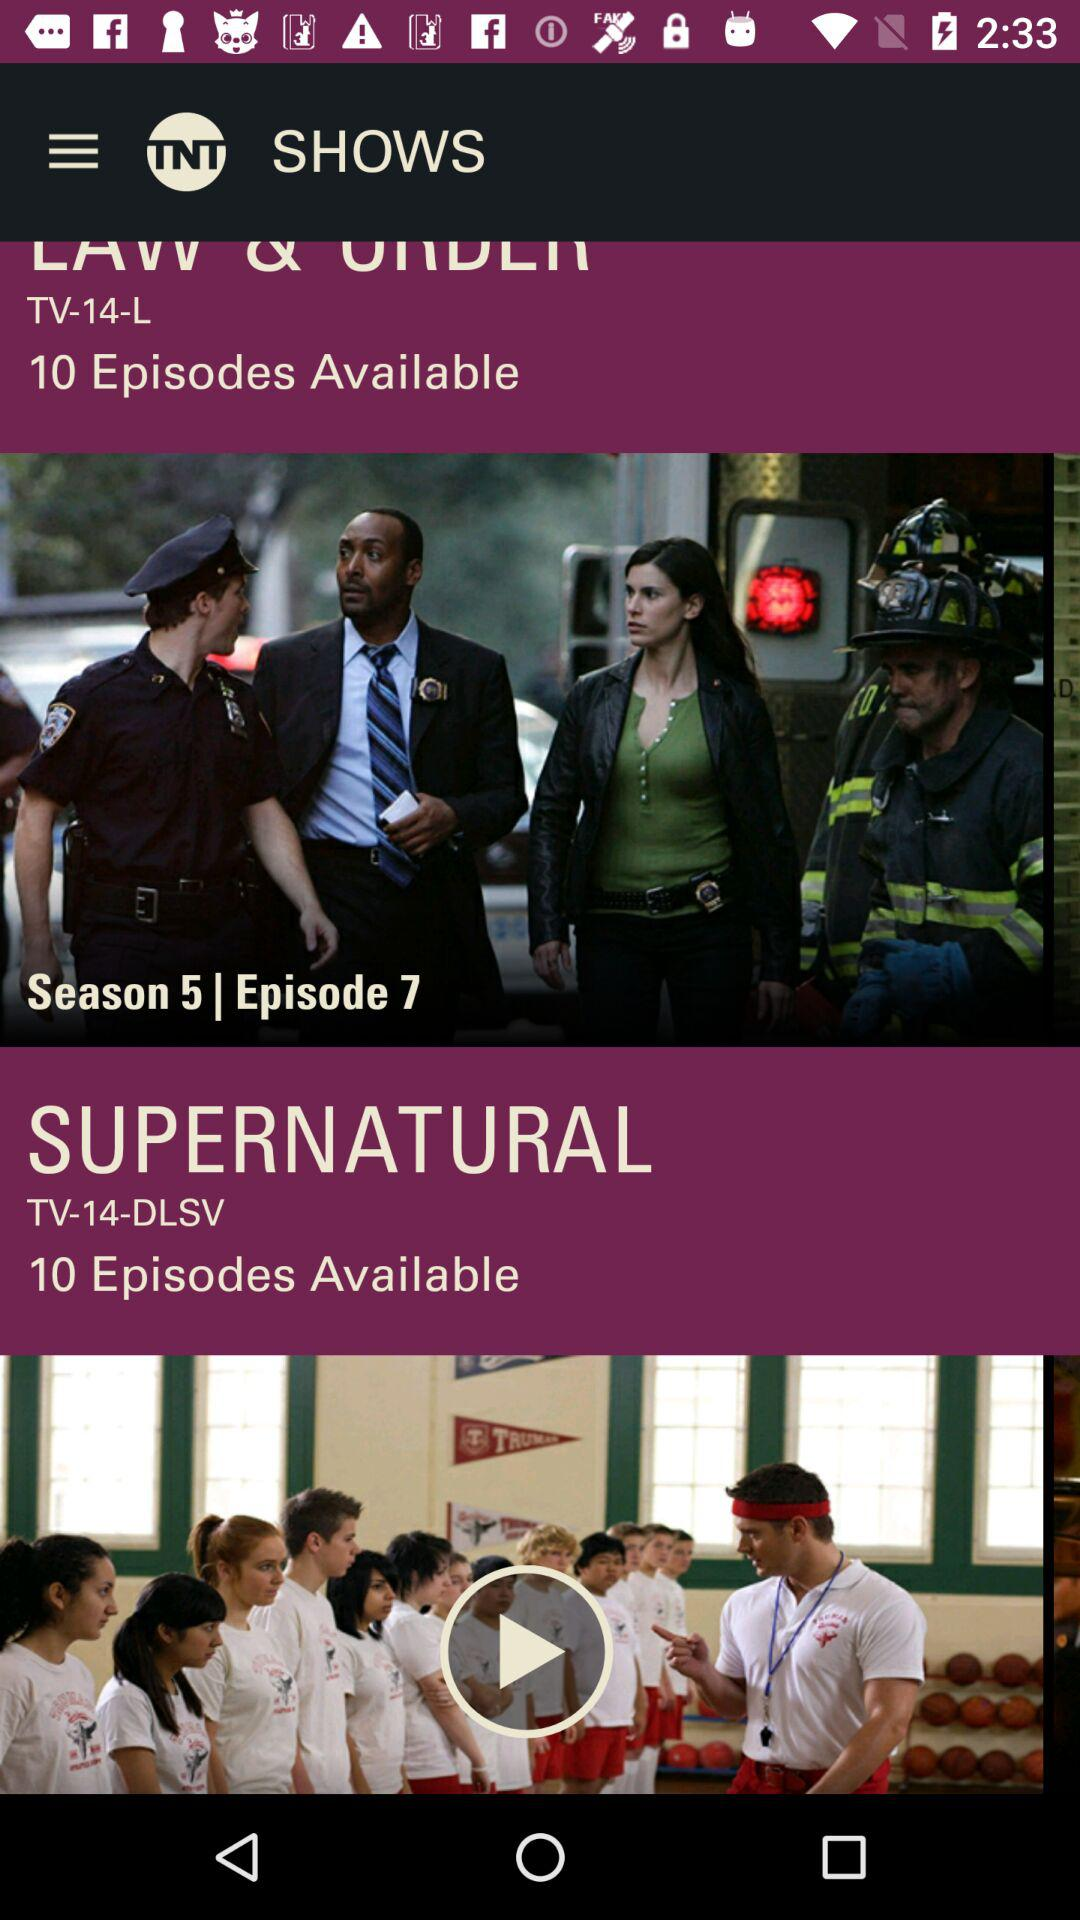How many episodes are available? There are 10 episodes available. 